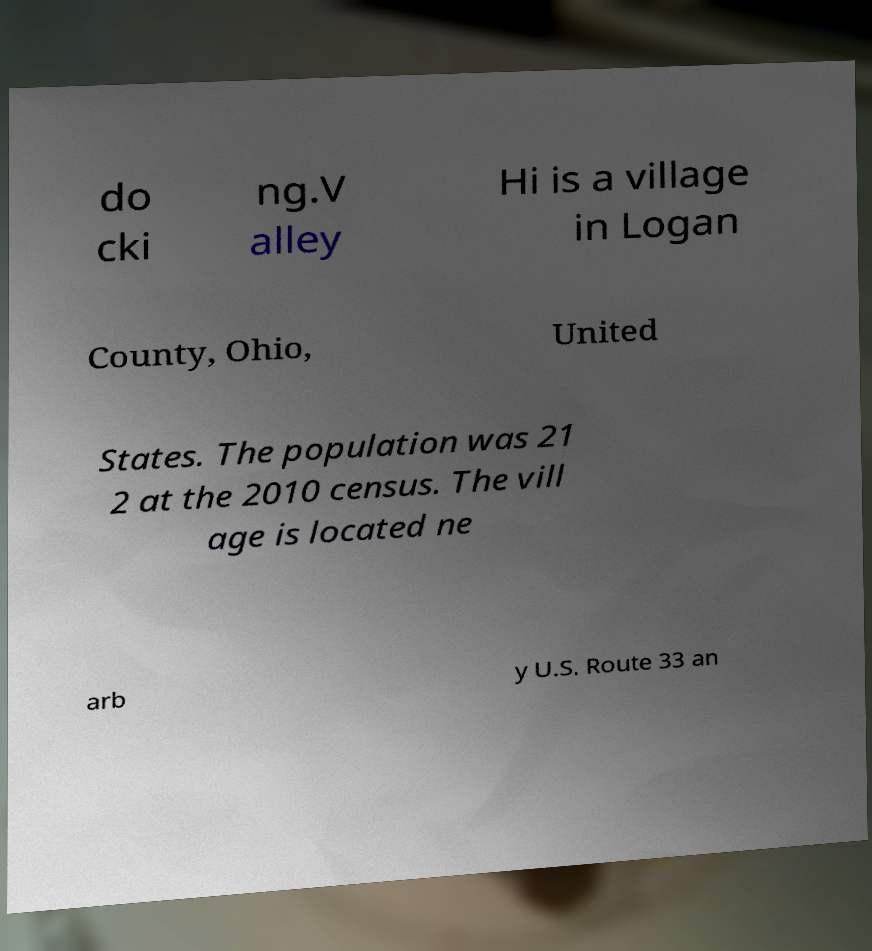Could you assist in decoding the text presented in this image and type it out clearly? do cki ng.V alley Hi is a village in Logan County, Ohio, United States. The population was 21 2 at the 2010 census. The vill age is located ne arb y U.S. Route 33 an 